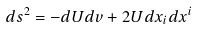<formula> <loc_0><loc_0><loc_500><loc_500>d s ^ { 2 } = - d U d v + 2 U d x _ { i } d x ^ { i }</formula> 